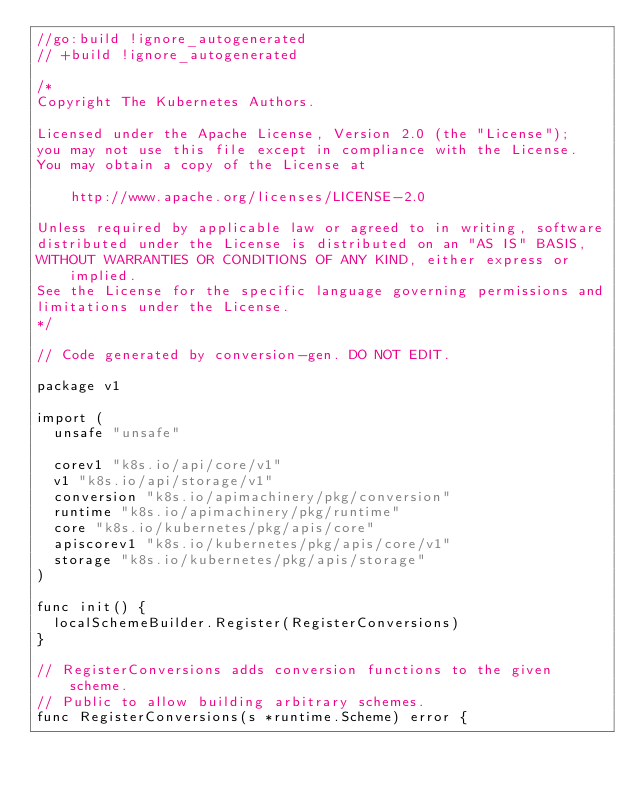<code> <loc_0><loc_0><loc_500><loc_500><_Go_>//go:build !ignore_autogenerated
// +build !ignore_autogenerated

/*
Copyright The Kubernetes Authors.

Licensed under the Apache License, Version 2.0 (the "License");
you may not use this file except in compliance with the License.
You may obtain a copy of the License at

    http://www.apache.org/licenses/LICENSE-2.0

Unless required by applicable law or agreed to in writing, software
distributed under the License is distributed on an "AS IS" BASIS,
WITHOUT WARRANTIES OR CONDITIONS OF ANY KIND, either express or implied.
See the License for the specific language governing permissions and
limitations under the License.
*/

// Code generated by conversion-gen. DO NOT EDIT.

package v1

import (
	unsafe "unsafe"

	corev1 "k8s.io/api/core/v1"
	v1 "k8s.io/api/storage/v1"
	conversion "k8s.io/apimachinery/pkg/conversion"
	runtime "k8s.io/apimachinery/pkg/runtime"
	core "k8s.io/kubernetes/pkg/apis/core"
	apiscorev1 "k8s.io/kubernetes/pkg/apis/core/v1"
	storage "k8s.io/kubernetes/pkg/apis/storage"
)

func init() {
	localSchemeBuilder.Register(RegisterConversions)
}

// RegisterConversions adds conversion functions to the given scheme.
// Public to allow building arbitrary schemes.
func RegisterConversions(s *runtime.Scheme) error {</code> 